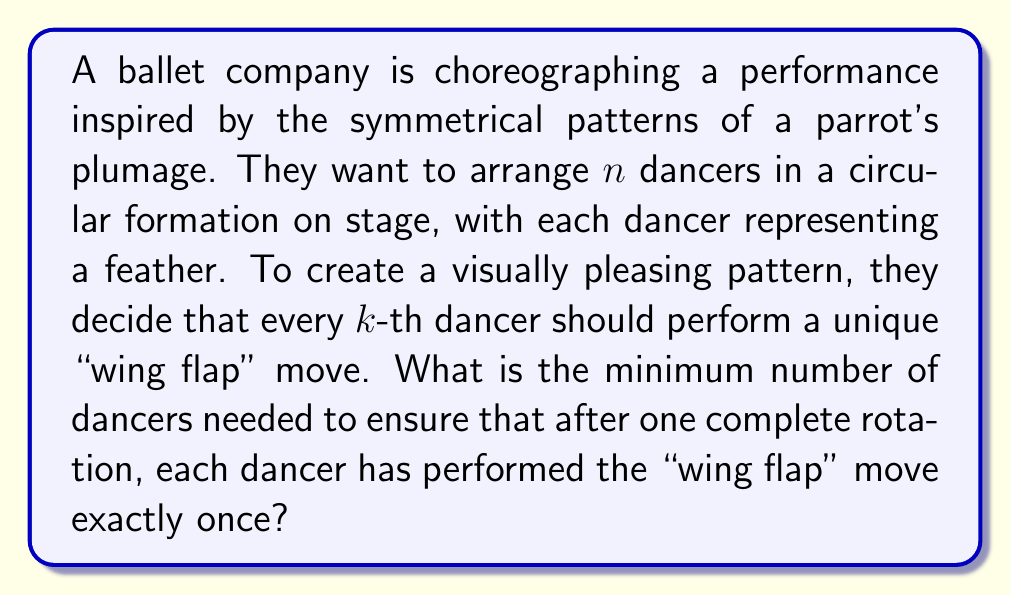Could you help me with this problem? To solve this problem, we need to consider the concept of modular arithmetic and the least common multiple (LCM).

1) Let's consider the dancers numbered from 1 to $n$.

2) The "wing flap" move will be performed by dancers at positions that are multiples of $k$: $k, 2k, 3k, ...$

3) For the pattern to repeat exactly once after a full rotation, we need:
   $n \equiv 0 \pmod{k}$ (n should be divisible by k)
   AND
   $n$ and $k$ should be coprime (their greatest common divisor should be 1)

4) The smallest such $n$ that satisfies both conditions is the least common multiple of $k$ and the numbers from 1 to $k-1$.

5) Therefore, the minimum number of dancers needed is:

   $$n = LCM(k, k-1, k-2, ..., 3, 2, 1)$$

6) This value of $n$ ensures that after one complete rotation, each dancer will have performed the "wing flap" move exactly once, creating a symmetrical and visually pleasing pattern reminiscent of a parrot's plumage.

For example, if $k = 4$:
$$n = LCM(4, 3, 2, 1) = 12$$

We can verify:
- Dancer 4 flaps: 4, 8, 12
- Dancer 3 flaps: 3, 7, 11
- Dancer 2 flaps: 2, 6, 10
- Dancer 1 flaps: 1, 5, 9

After 12 positions, the pattern repeats, and each dancer has flapped exactly once.
Answer: The minimum number of dancers needed is:
$$n = LCM(k, k-1, k-2, ..., 3, 2, 1)$$
where $k$ is the interval at which the "wing flap" move is performed. 